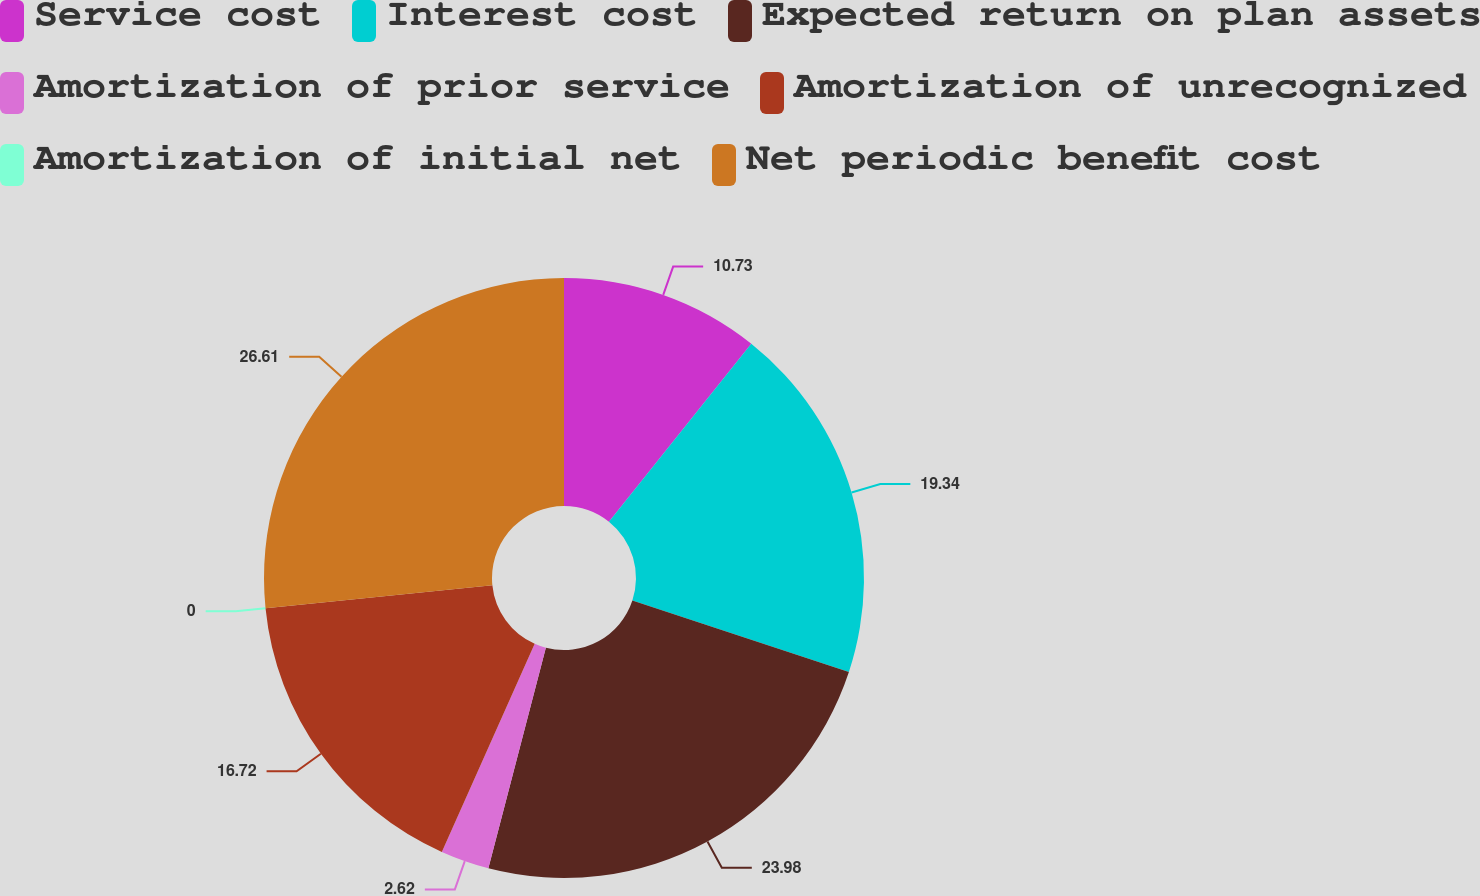<chart> <loc_0><loc_0><loc_500><loc_500><pie_chart><fcel>Service cost<fcel>Interest cost<fcel>Expected return on plan assets<fcel>Amortization of prior service<fcel>Amortization of unrecognized<fcel>Amortization of initial net<fcel>Net periodic benefit cost<nl><fcel>10.73%<fcel>19.34%<fcel>23.98%<fcel>2.62%<fcel>16.72%<fcel>0.0%<fcel>26.6%<nl></chart> 